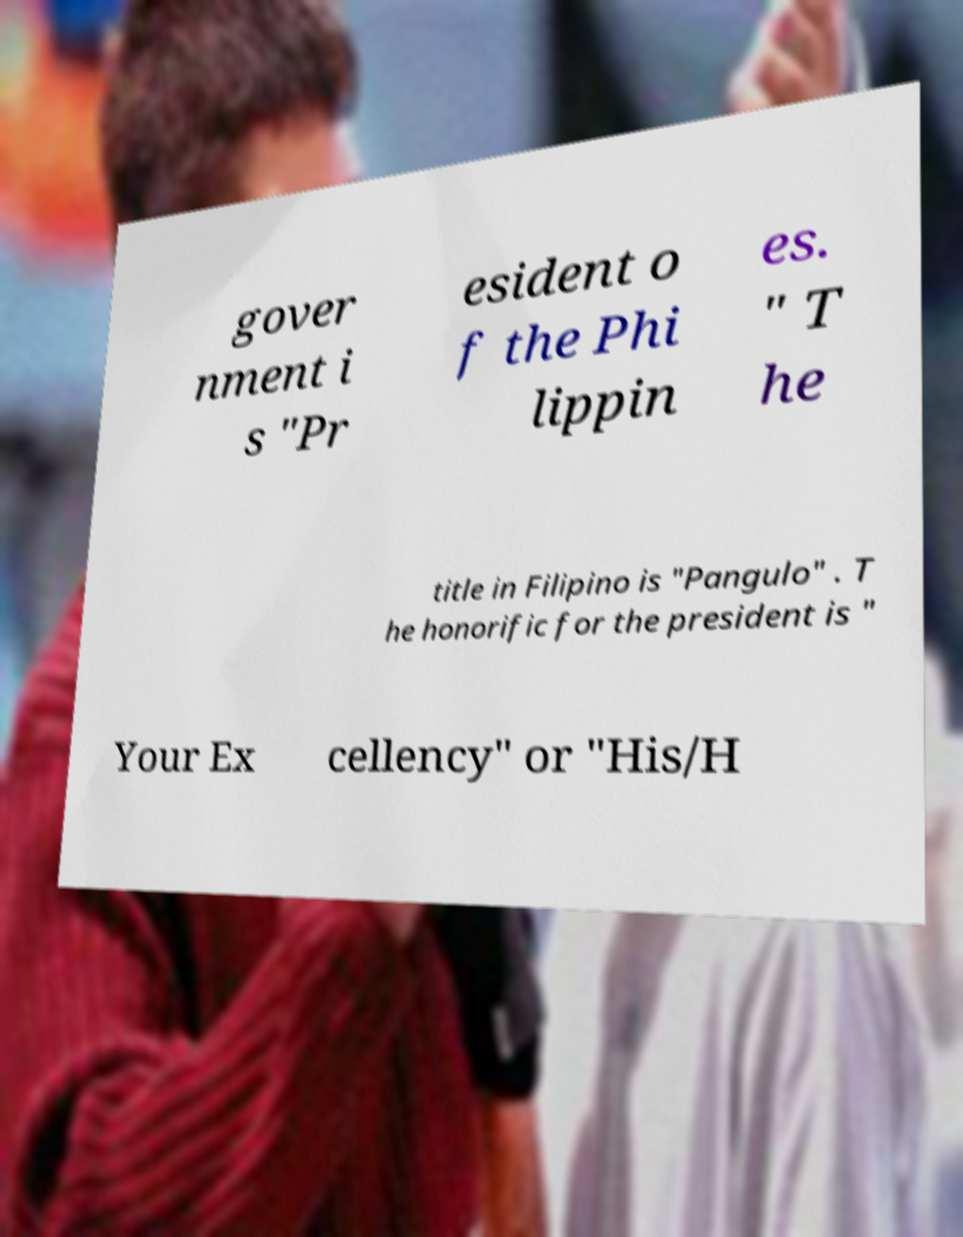For documentation purposes, I need the text within this image transcribed. Could you provide that? gover nment i s "Pr esident o f the Phi lippin es. " T he title in Filipino is "Pangulo" . T he honorific for the president is " Your Ex cellency" or "His/H 